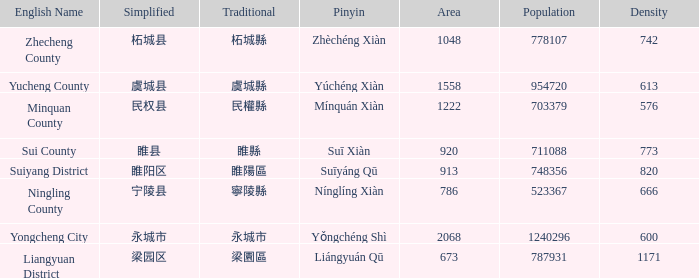What is the traditional with density of 820? 睢陽區. 